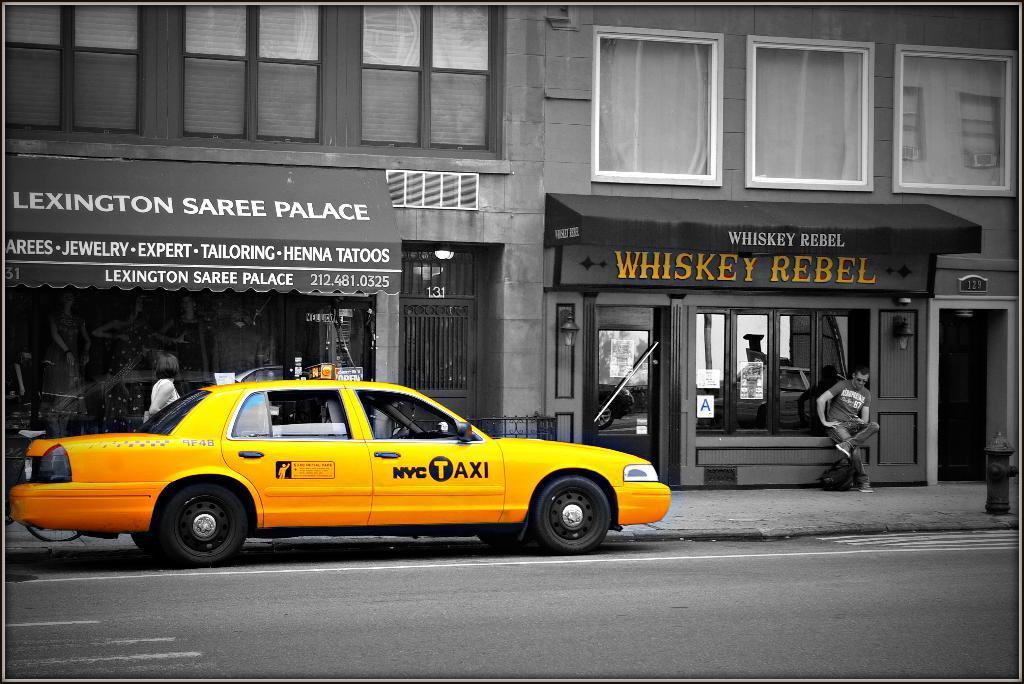How would you summarize this image in a sentence or two? This image is taken outdoors. This image is an edited image. At the bottom of the image there is a road. In the background there are two buildings. There are two boards with text on them. A man is sitting on the bench and a woman is walking on the sidewalk. On the left side of the image a car is parked on the road. The car is yellow in color. 